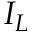Convert formula to latex. <formula><loc_0><loc_0><loc_500><loc_500>I _ { L }</formula> 